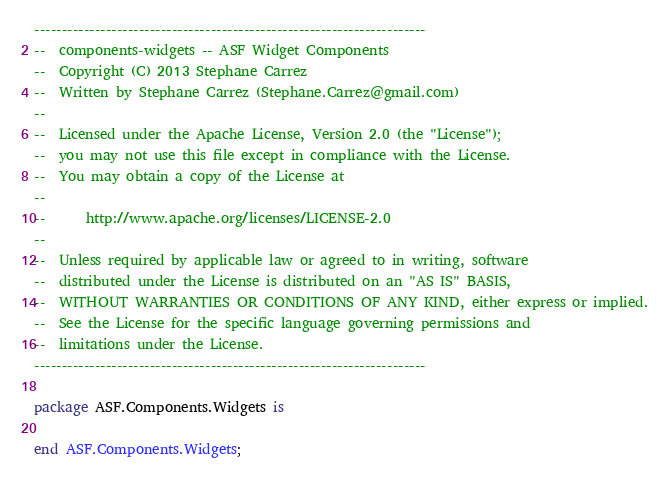<code> <loc_0><loc_0><loc_500><loc_500><_Ada_>-----------------------------------------------------------------------
--  components-widgets -- ASF Widget Components
--  Copyright (C) 2013 Stephane Carrez
--  Written by Stephane Carrez (Stephane.Carrez@gmail.com)
--
--  Licensed under the Apache License, Version 2.0 (the "License");
--  you may not use this file except in compliance with the License.
--  You may obtain a copy of the License at
--
--      http://www.apache.org/licenses/LICENSE-2.0
--
--  Unless required by applicable law or agreed to in writing, software
--  distributed under the License is distributed on an "AS IS" BASIS,
--  WITHOUT WARRANTIES OR CONDITIONS OF ANY KIND, either express or implied.
--  See the License for the specific language governing permissions and
--  limitations under the License.
-----------------------------------------------------------------------

package ASF.Components.Widgets is

end ASF.Components.Widgets;
</code> 